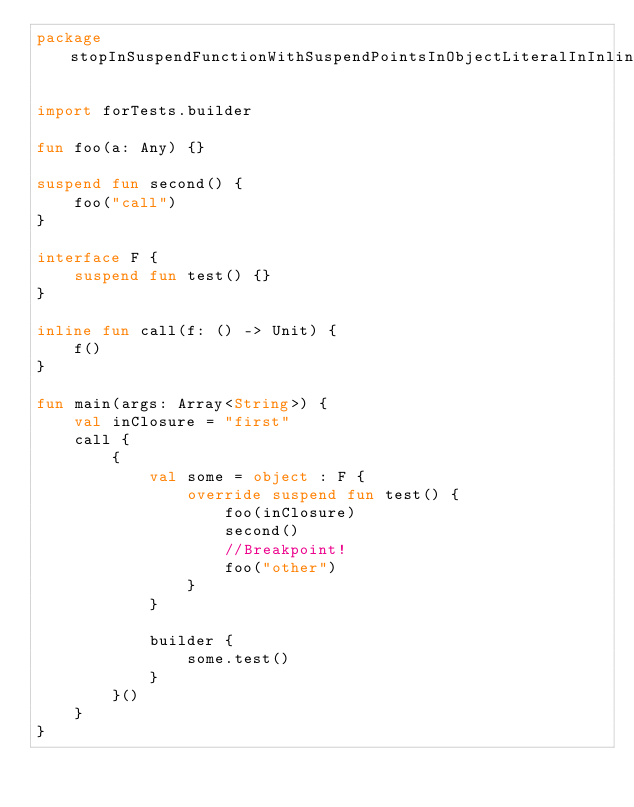Convert code to text. <code><loc_0><loc_0><loc_500><loc_500><_Kotlin_>package stopInSuspendFunctionWithSuspendPointsInObjectLiteralInInlineCallWithClosure

import forTests.builder

fun foo(a: Any) {}

suspend fun second() {
    foo("call")
}

interface F {
    suspend fun test() {}
}

inline fun call(f: () -> Unit) {
    f()
}

fun main(args: Array<String>) {
    val inClosure = "first"
    call {
        {
            val some = object : F {
                override suspend fun test() {
                    foo(inClosure)
                    second()
                    //Breakpoint!
                    foo("other")
                }
            }

            builder {
                some.test()
            }
        }()
    }
}
</code> 